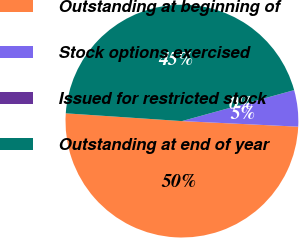<chart> <loc_0><loc_0><loc_500><loc_500><pie_chart><fcel>Outstanding at beginning of<fcel>Stock options exercised<fcel>Issued for restricted stock<fcel>Outstanding at end of year<nl><fcel>50.3%<fcel>5.04%<fcel>0.01%<fcel>44.65%<nl></chart> 